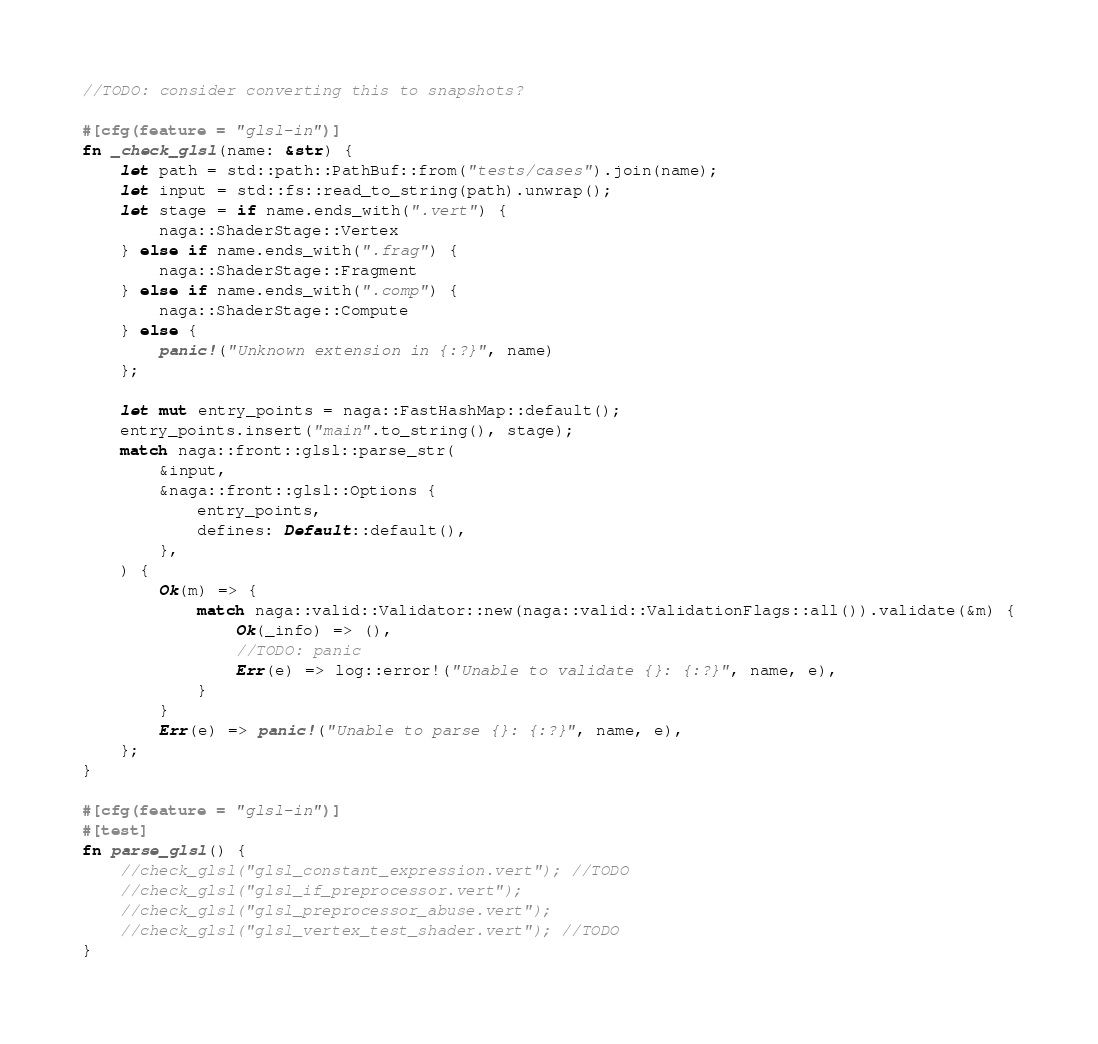Convert code to text. <code><loc_0><loc_0><loc_500><loc_500><_Rust_>//TODO: consider converting this to snapshots?

#[cfg(feature = "glsl-in")]
fn _check_glsl(name: &str) {
    let path = std::path::PathBuf::from("tests/cases").join(name);
    let input = std::fs::read_to_string(path).unwrap();
    let stage = if name.ends_with(".vert") {
        naga::ShaderStage::Vertex
    } else if name.ends_with(".frag") {
        naga::ShaderStage::Fragment
    } else if name.ends_with(".comp") {
        naga::ShaderStage::Compute
    } else {
        panic!("Unknown extension in {:?}", name)
    };

    let mut entry_points = naga::FastHashMap::default();
    entry_points.insert("main".to_string(), stage);
    match naga::front::glsl::parse_str(
        &input,
        &naga::front::glsl::Options {
            entry_points,
            defines: Default::default(),
        },
    ) {
        Ok(m) => {
            match naga::valid::Validator::new(naga::valid::ValidationFlags::all()).validate(&m) {
                Ok(_info) => (),
                //TODO: panic
                Err(e) => log::error!("Unable to validate {}: {:?}", name, e),
            }
        }
        Err(e) => panic!("Unable to parse {}: {:?}", name, e),
    };
}

#[cfg(feature = "glsl-in")]
#[test]
fn parse_glsl() {
    //check_glsl("glsl_constant_expression.vert"); //TODO
    //check_glsl("glsl_if_preprocessor.vert");
    //check_glsl("glsl_preprocessor_abuse.vert");
    //check_glsl("glsl_vertex_test_shader.vert"); //TODO
}
</code> 